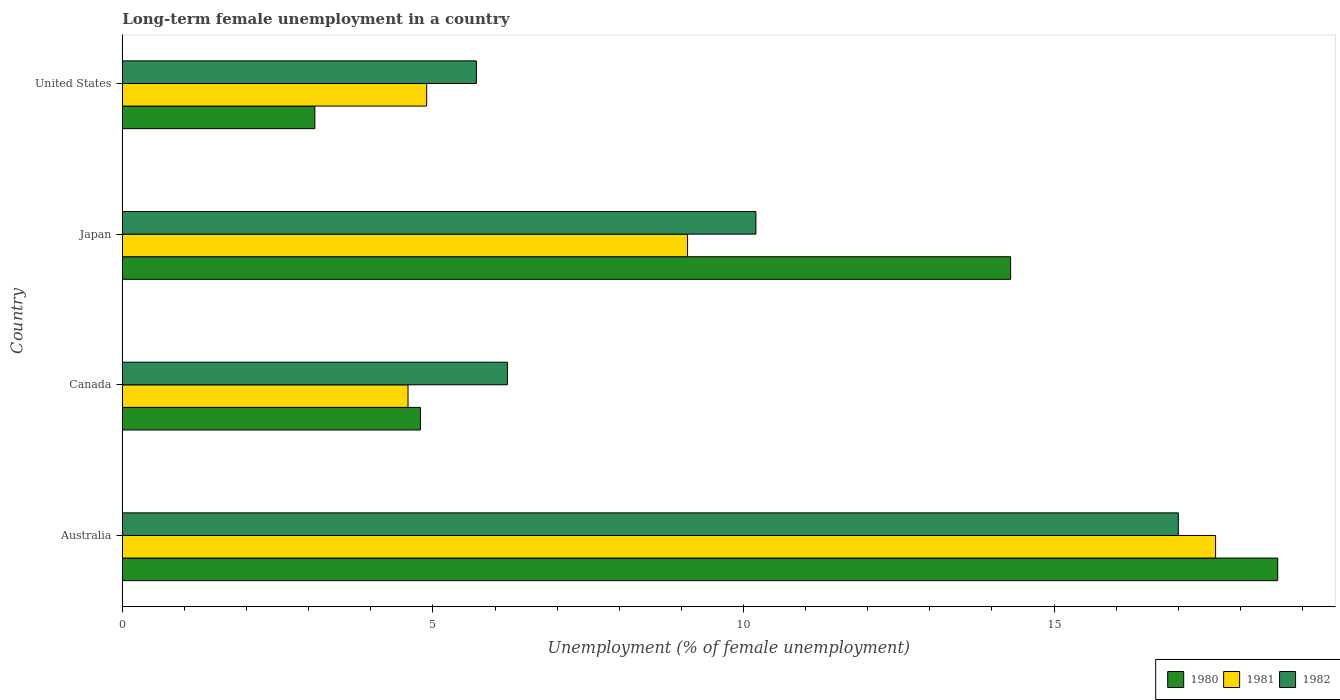How many different coloured bars are there?
Your answer should be compact. 3. Are the number of bars per tick equal to the number of legend labels?
Give a very brief answer. Yes. Are the number of bars on each tick of the Y-axis equal?
Provide a succinct answer. Yes. How many bars are there on the 4th tick from the top?
Offer a very short reply. 3. How many bars are there on the 4th tick from the bottom?
Provide a short and direct response. 3. What is the percentage of long-term unemployed female population in 1981 in Japan?
Provide a succinct answer. 9.1. Across all countries, what is the maximum percentage of long-term unemployed female population in 1981?
Provide a short and direct response. 17.6. Across all countries, what is the minimum percentage of long-term unemployed female population in 1981?
Your answer should be very brief. 4.6. What is the total percentage of long-term unemployed female population in 1980 in the graph?
Ensure brevity in your answer.  40.8. What is the difference between the percentage of long-term unemployed female population in 1982 in Australia and that in Canada?
Ensure brevity in your answer.  10.8. What is the difference between the percentage of long-term unemployed female population in 1982 in Japan and the percentage of long-term unemployed female population in 1981 in Canada?
Give a very brief answer. 5.6. What is the average percentage of long-term unemployed female population in 1980 per country?
Give a very brief answer. 10.2. What is the difference between the percentage of long-term unemployed female population in 1982 and percentage of long-term unemployed female population in 1981 in Japan?
Keep it short and to the point. 1.1. In how many countries, is the percentage of long-term unemployed female population in 1982 greater than 4 %?
Your response must be concise. 4. What is the ratio of the percentage of long-term unemployed female population in 1981 in Australia to that in United States?
Your response must be concise. 3.59. Is the percentage of long-term unemployed female population in 1982 in Canada less than that in Japan?
Your response must be concise. Yes. Is the difference between the percentage of long-term unemployed female population in 1982 in Japan and United States greater than the difference between the percentage of long-term unemployed female population in 1981 in Japan and United States?
Provide a succinct answer. Yes. What is the difference between the highest and the second highest percentage of long-term unemployed female population in 1980?
Give a very brief answer. 4.3. What is the difference between the highest and the lowest percentage of long-term unemployed female population in 1981?
Provide a succinct answer. 13. What does the 2nd bar from the bottom in Canada represents?
Keep it short and to the point. 1981. How many bars are there?
Keep it short and to the point. 12. Are the values on the major ticks of X-axis written in scientific E-notation?
Your answer should be very brief. No. Where does the legend appear in the graph?
Make the answer very short. Bottom right. How many legend labels are there?
Make the answer very short. 3. What is the title of the graph?
Give a very brief answer. Long-term female unemployment in a country. What is the label or title of the X-axis?
Give a very brief answer. Unemployment (% of female unemployment). What is the label or title of the Y-axis?
Your answer should be compact. Country. What is the Unemployment (% of female unemployment) in 1980 in Australia?
Give a very brief answer. 18.6. What is the Unemployment (% of female unemployment) of 1981 in Australia?
Make the answer very short. 17.6. What is the Unemployment (% of female unemployment) in 1982 in Australia?
Provide a short and direct response. 17. What is the Unemployment (% of female unemployment) in 1980 in Canada?
Offer a very short reply. 4.8. What is the Unemployment (% of female unemployment) of 1981 in Canada?
Offer a very short reply. 4.6. What is the Unemployment (% of female unemployment) in 1982 in Canada?
Your answer should be compact. 6.2. What is the Unemployment (% of female unemployment) in 1980 in Japan?
Offer a terse response. 14.3. What is the Unemployment (% of female unemployment) of 1981 in Japan?
Your answer should be very brief. 9.1. What is the Unemployment (% of female unemployment) in 1982 in Japan?
Offer a very short reply. 10.2. What is the Unemployment (% of female unemployment) of 1980 in United States?
Your answer should be very brief. 3.1. What is the Unemployment (% of female unemployment) of 1981 in United States?
Make the answer very short. 4.9. What is the Unemployment (% of female unemployment) of 1982 in United States?
Offer a very short reply. 5.7. Across all countries, what is the maximum Unemployment (% of female unemployment) of 1980?
Provide a succinct answer. 18.6. Across all countries, what is the maximum Unemployment (% of female unemployment) of 1981?
Ensure brevity in your answer.  17.6. Across all countries, what is the maximum Unemployment (% of female unemployment) of 1982?
Offer a terse response. 17. Across all countries, what is the minimum Unemployment (% of female unemployment) of 1980?
Your response must be concise. 3.1. Across all countries, what is the minimum Unemployment (% of female unemployment) in 1981?
Offer a very short reply. 4.6. Across all countries, what is the minimum Unemployment (% of female unemployment) of 1982?
Provide a succinct answer. 5.7. What is the total Unemployment (% of female unemployment) of 1980 in the graph?
Your response must be concise. 40.8. What is the total Unemployment (% of female unemployment) of 1981 in the graph?
Your answer should be very brief. 36.2. What is the total Unemployment (% of female unemployment) of 1982 in the graph?
Offer a very short reply. 39.1. What is the difference between the Unemployment (% of female unemployment) in 1980 in Australia and that in Japan?
Ensure brevity in your answer.  4.3. What is the difference between the Unemployment (% of female unemployment) of 1981 in Australia and that in Japan?
Offer a very short reply. 8.5. What is the difference between the Unemployment (% of female unemployment) of 1982 in Australia and that in Japan?
Provide a short and direct response. 6.8. What is the difference between the Unemployment (% of female unemployment) in 1981 in Australia and that in United States?
Offer a terse response. 12.7. What is the difference between the Unemployment (% of female unemployment) of 1980 in Canada and that in Japan?
Make the answer very short. -9.5. What is the difference between the Unemployment (% of female unemployment) in 1980 in Canada and that in United States?
Your answer should be compact. 1.7. What is the difference between the Unemployment (% of female unemployment) in 1981 in Canada and that in United States?
Keep it short and to the point. -0.3. What is the difference between the Unemployment (% of female unemployment) in 1982 in Canada and that in United States?
Provide a short and direct response. 0.5. What is the difference between the Unemployment (% of female unemployment) of 1980 in Japan and that in United States?
Your answer should be compact. 11.2. What is the difference between the Unemployment (% of female unemployment) of 1981 in Japan and that in United States?
Your answer should be very brief. 4.2. What is the difference between the Unemployment (% of female unemployment) in 1980 in Australia and the Unemployment (% of female unemployment) in 1981 in Canada?
Your answer should be very brief. 14. What is the difference between the Unemployment (% of female unemployment) of 1980 in Australia and the Unemployment (% of female unemployment) of 1981 in Japan?
Keep it short and to the point. 9.5. What is the difference between the Unemployment (% of female unemployment) of 1980 in Australia and the Unemployment (% of female unemployment) of 1982 in Japan?
Provide a short and direct response. 8.4. What is the difference between the Unemployment (% of female unemployment) in 1980 in Australia and the Unemployment (% of female unemployment) in 1982 in United States?
Offer a very short reply. 12.9. What is the difference between the Unemployment (% of female unemployment) of 1981 in Australia and the Unemployment (% of female unemployment) of 1982 in United States?
Ensure brevity in your answer.  11.9. What is the difference between the Unemployment (% of female unemployment) of 1981 in Canada and the Unemployment (% of female unemployment) of 1982 in Japan?
Your answer should be compact. -5.6. What is the difference between the Unemployment (% of female unemployment) of 1980 in Canada and the Unemployment (% of female unemployment) of 1982 in United States?
Your answer should be compact. -0.9. What is the difference between the Unemployment (% of female unemployment) in 1981 in Canada and the Unemployment (% of female unemployment) in 1982 in United States?
Offer a terse response. -1.1. What is the difference between the Unemployment (% of female unemployment) in 1980 in Japan and the Unemployment (% of female unemployment) in 1982 in United States?
Ensure brevity in your answer.  8.6. What is the difference between the Unemployment (% of female unemployment) of 1981 in Japan and the Unemployment (% of female unemployment) of 1982 in United States?
Make the answer very short. 3.4. What is the average Unemployment (% of female unemployment) of 1981 per country?
Offer a terse response. 9.05. What is the average Unemployment (% of female unemployment) of 1982 per country?
Give a very brief answer. 9.78. What is the difference between the Unemployment (% of female unemployment) of 1980 and Unemployment (% of female unemployment) of 1981 in Australia?
Offer a terse response. 1. What is the difference between the Unemployment (% of female unemployment) in 1980 and Unemployment (% of female unemployment) in 1982 in Australia?
Make the answer very short. 1.6. What is the difference between the Unemployment (% of female unemployment) of 1980 and Unemployment (% of female unemployment) of 1981 in Canada?
Give a very brief answer. 0.2. What is the difference between the Unemployment (% of female unemployment) in 1980 and Unemployment (% of female unemployment) in 1981 in Japan?
Provide a short and direct response. 5.2. What is the difference between the Unemployment (% of female unemployment) in 1980 and Unemployment (% of female unemployment) in 1982 in Japan?
Your response must be concise. 4.1. What is the difference between the Unemployment (% of female unemployment) of 1981 and Unemployment (% of female unemployment) of 1982 in Japan?
Provide a short and direct response. -1.1. What is the difference between the Unemployment (% of female unemployment) of 1980 and Unemployment (% of female unemployment) of 1981 in United States?
Provide a succinct answer. -1.8. What is the difference between the Unemployment (% of female unemployment) in 1981 and Unemployment (% of female unemployment) in 1982 in United States?
Provide a short and direct response. -0.8. What is the ratio of the Unemployment (% of female unemployment) of 1980 in Australia to that in Canada?
Offer a very short reply. 3.88. What is the ratio of the Unemployment (% of female unemployment) of 1981 in Australia to that in Canada?
Offer a very short reply. 3.83. What is the ratio of the Unemployment (% of female unemployment) of 1982 in Australia to that in Canada?
Your answer should be compact. 2.74. What is the ratio of the Unemployment (% of female unemployment) of 1980 in Australia to that in Japan?
Your answer should be very brief. 1.3. What is the ratio of the Unemployment (% of female unemployment) of 1981 in Australia to that in Japan?
Make the answer very short. 1.93. What is the ratio of the Unemployment (% of female unemployment) in 1981 in Australia to that in United States?
Make the answer very short. 3.59. What is the ratio of the Unemployment (% of female unemployment) in 1982 in Australia to that in United States?
Offer a very short reply. 2.98. What is the ratio of the Unemployment (% of female unemployment) in 1980 in Canada to that in Japan?
Offer a very short reply. 0.34. What is the ratio of the Unemployment (% of female unemployment) of 1981 in Canada to that in Japan?
Keep it short and to the point. 0.51. What is the ratio of the Unemployment (% of female unemployment) of 1982 in Canada to that in Japan?
Your answer should be very brief. 0.61. What is the ratio of the Unemployment (% of female unemployment) in 1980 in Canada to that in United States?
Offer a terse response. 1.55. What is the ratio of the Unemployment (% of female unemployment) of 1981 in Canada to that in United States?
Your response must be concise. 0.94. What is the ratio of the Unemployment (% of female unemployment) of 1982 in Canada to that in United States?
Make the answer very short. 1.09. What is the ratio of the Unemployment (% of female unemployment) in 1980 in Japan to that in United States?
Ensure brevity in your answer.  4.61. What is the ratio of the Unemployment (% of female unemployment) in 1981 in Japan to that in United States?
Your answer should be very brief. 1.86. What is the ratio of the Unemployment (% of female unemployment) of 1982 in Japan to that in United States?
Your response must be concise. 1.79. What is the difference between the highest and the second highest Unemployment (% of female unemployment) of 1980?
Offer a terse response. 4.3. What is the difference between the highest and the second highest Unemployment (% of female unemployment) of 1981?
Provide a short and direct response. 8.5. What is the difference between the highest and the lowest Unemployment (% of female unemployment) in 1982?
Make the answer very short. 11.3. 